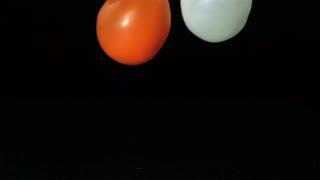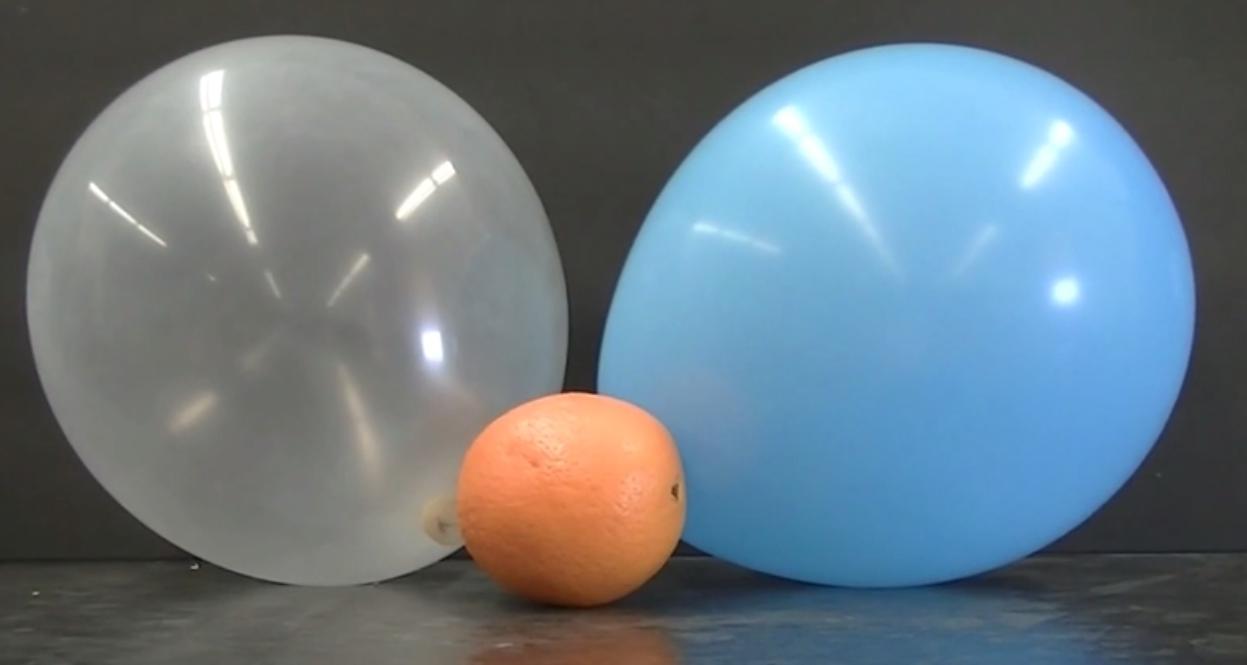The first image is the image on the left, the second image is the image on the right. Analyze the images presented: Is the assertion "One of the balloons is bright pink." valid? Answer yes or no. No. The first image is the image on the left, the second image is the image on the right. For the images displayed, is the sentence "One image includes a lumpy-looking green balloon, and the other image includes at least two balloons of different colors." factually correct? Answer yes or no. No. 